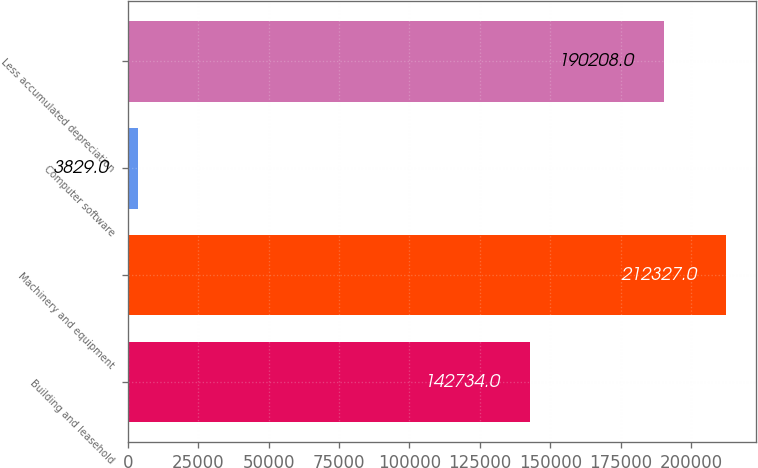Convert chart. <chart><loc_0><loc_0><loc_500><loc_500><bar_chart><fcel>Building and leasehold<fcel>Machinery and equipment<fcel>Computer software<fcel>Less accumulated depreciation<nl><fcel>142734<fcel>212327<fcel>3829<fcel>190208<nl></chart> 